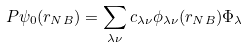Convert formula to latex. <formula><loc_0><loc_0><loc_500><loc_500>P \psi _ { 0 } ( { r } _ { N B } ) = \sum _ { \lambda \nu } c _ { \lambda \nu } \phi _ { \lambda \nu } ( { r } _ { N B } ) \Phi _ { \lambda }</formula> 